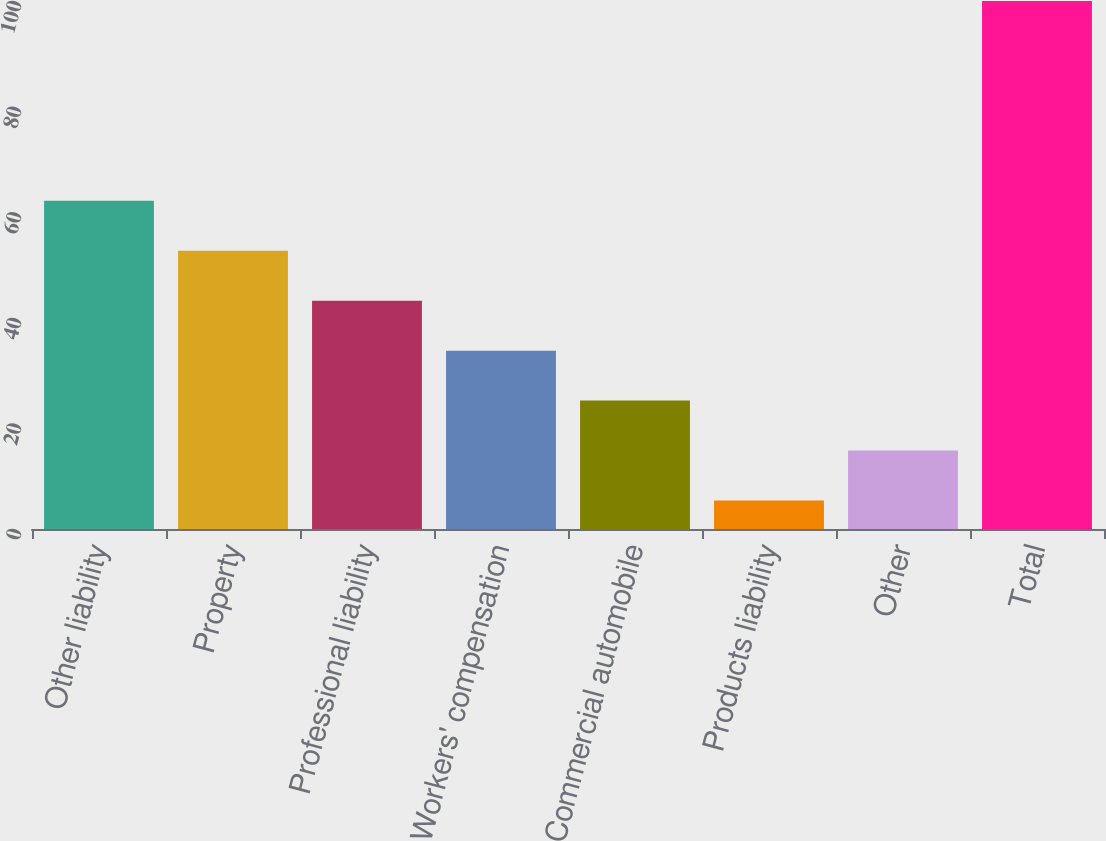<chart> <loc_0><loc_0><loc_500><loc_500><bar_chart><fcel>Other liability<fcel>Property<fcel>Professional liability<fcel>Workers' compensation<fcel>Commercial automobile<fcel>Products liability<fcel>Other<fcel>Total<nl><fcel>62.16<fcel>52.7<fcel>43.24<fcel>33.78<fcel>24.32<fcel>5.4<fcel>14.86<fcel>100<nl></chart> 